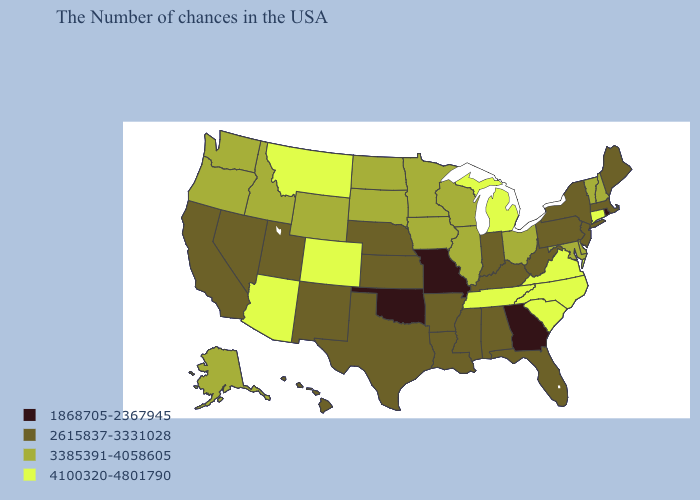Name the states that have a value in the range 4100320-4801790?
Short answer required. Connecticut, Virginia, North Carolina, South Carolina, Michigan, Tennessee, Colorado, Montana, Arizona. Name the states that have a value in the range 1868705-2367945?
Concise answer only. Rhode Island, Georgia, Missouri, Oklahoma. What is the value of Utah?
Answer briefly. 2615837-3331028. Does the first symbol in the legend represent the smallest category?
Give a very brief answer. Yes. Name the states that have a value in the range 2615837-3331028?
Keep it brief. Maine, Massachusetts, New York, New Jersey, Pennsylvania, West Virginia, Florida, Kentucky, Indiana, Alabama, Mississippi, Louisiana, Arkansas, Kansas, Nebraska, Texas, New Mexico, Utah, Nevada, California, Hawaii. What is the lowest value in the USA?
Answer briefly. 1868705-2367945. Among the states that border Vermont , which have the lowest value?
Be succinct. Massachusetts, New York. What is the value of Vermont?
Be succinct. 3385391-4058605. Does Minnesota have the highest value in the MidWest?
Short answer required. No. What is the highest value in the USA?
Short answer required. 4100320-4801790. Among the states that border Pennsylvania , which have the highest value?
Be succinct. Delaware, Maryland, Ohio. Does Alaska have the same value as Washington?
Quick response, please. Yes. What is the highest value in the USA?
Answer briefly. 4100320-4801790. Name the states that have a value in the range 3385391-4058605?
Write a very short answer. New Hampshire, Vermont, Delaware, Maryland, Ohio, Wisconsin, Illinois, Minnesota, Iowa, South Dakota, North Dakota, Wyoming, Idaho, Washington, Oregon, Alaska. 